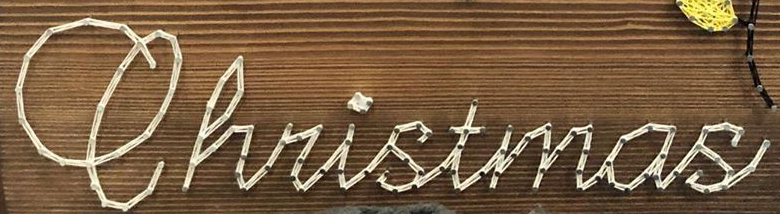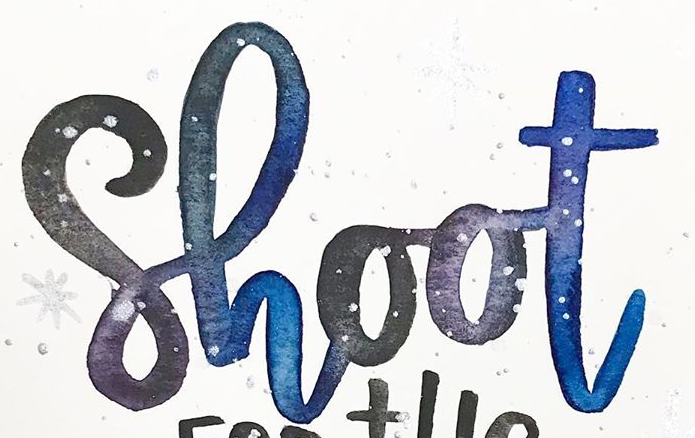What words are shown in these images in order, separated by a semicolon? Christmas; Shoot 